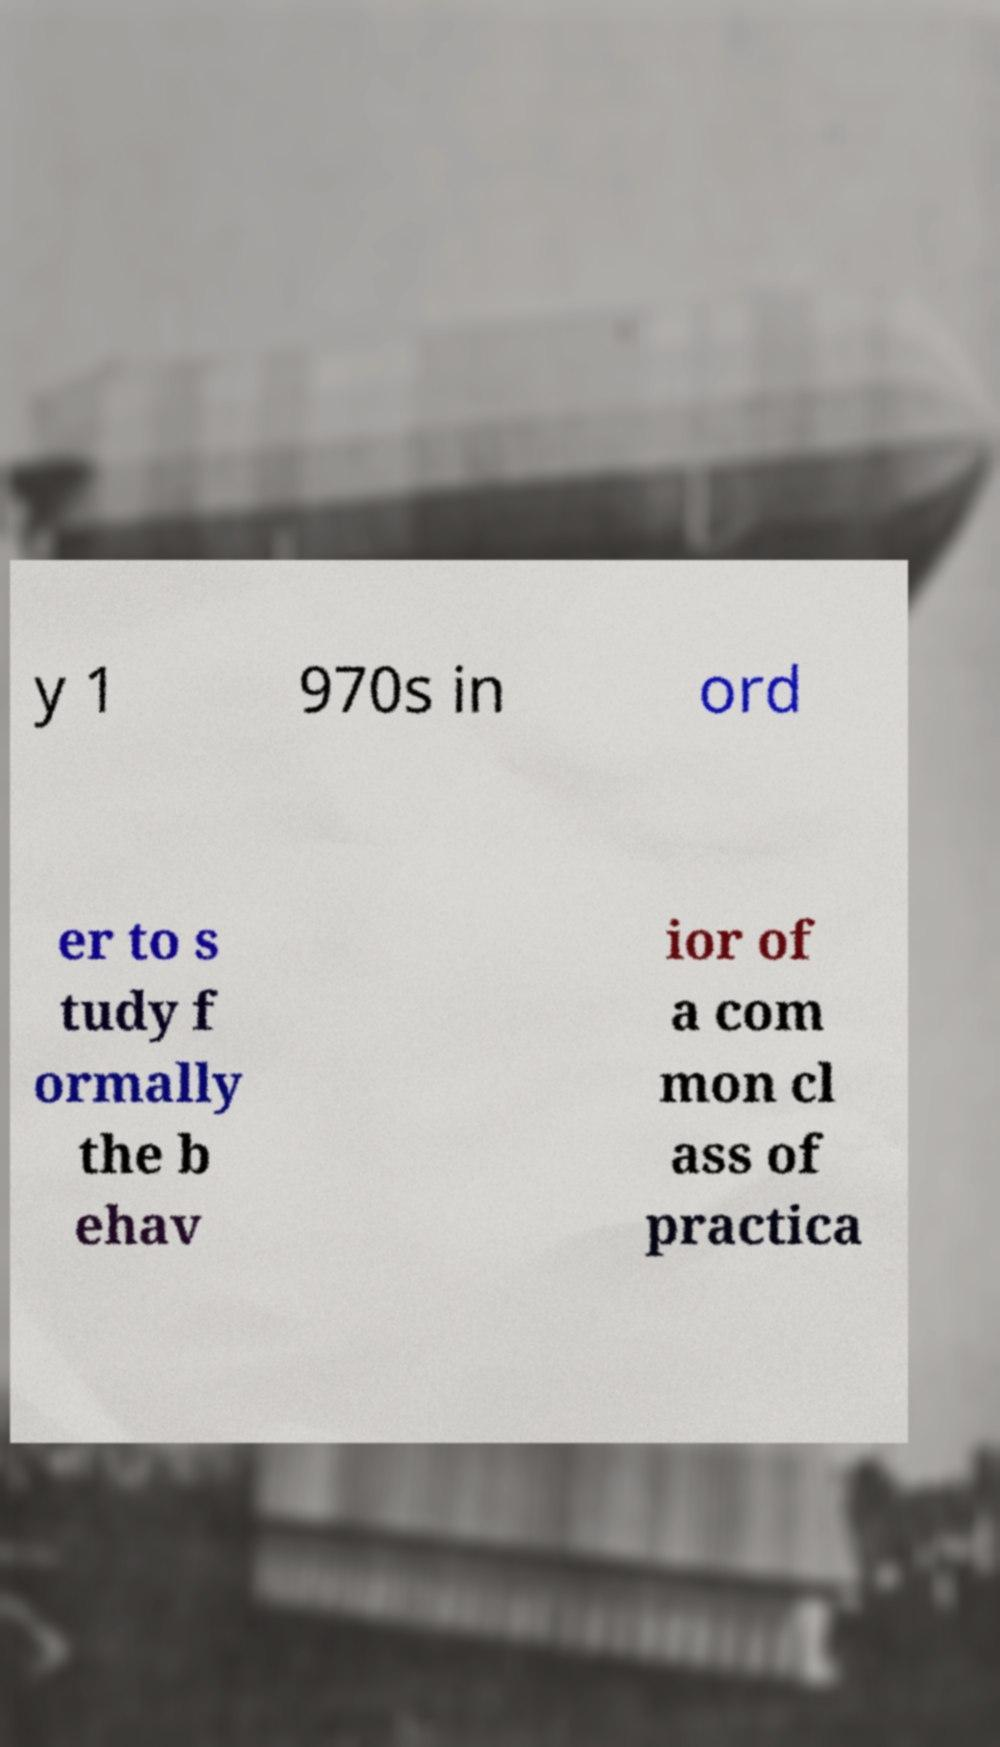Please identify and transcribe the text found in this image. y 1 970s in ord er to s tudy f ormally the b ehav ior of a com mon cl ass of practica 